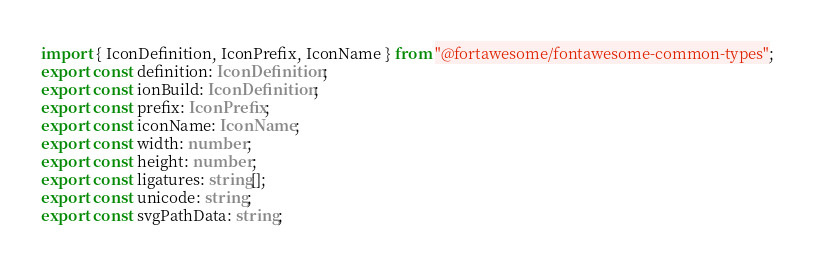Convert code to text. <code><loc_0><loc_0><loc_500><loc_500><_TypeScript_>import { IconDefinition, IconPrefix, IconName } from "@fortawesome/fontawesome-common-types";
export const definition: IconDefinition;
export const ionBuild: IconDefinition;
export const prefix: IconPrefix;
export const iconName: IconName;
export const width: number;
export const height: number;
export const ligatures: string[];
export const unicode: string;
export const svgPathData: string;</code> 